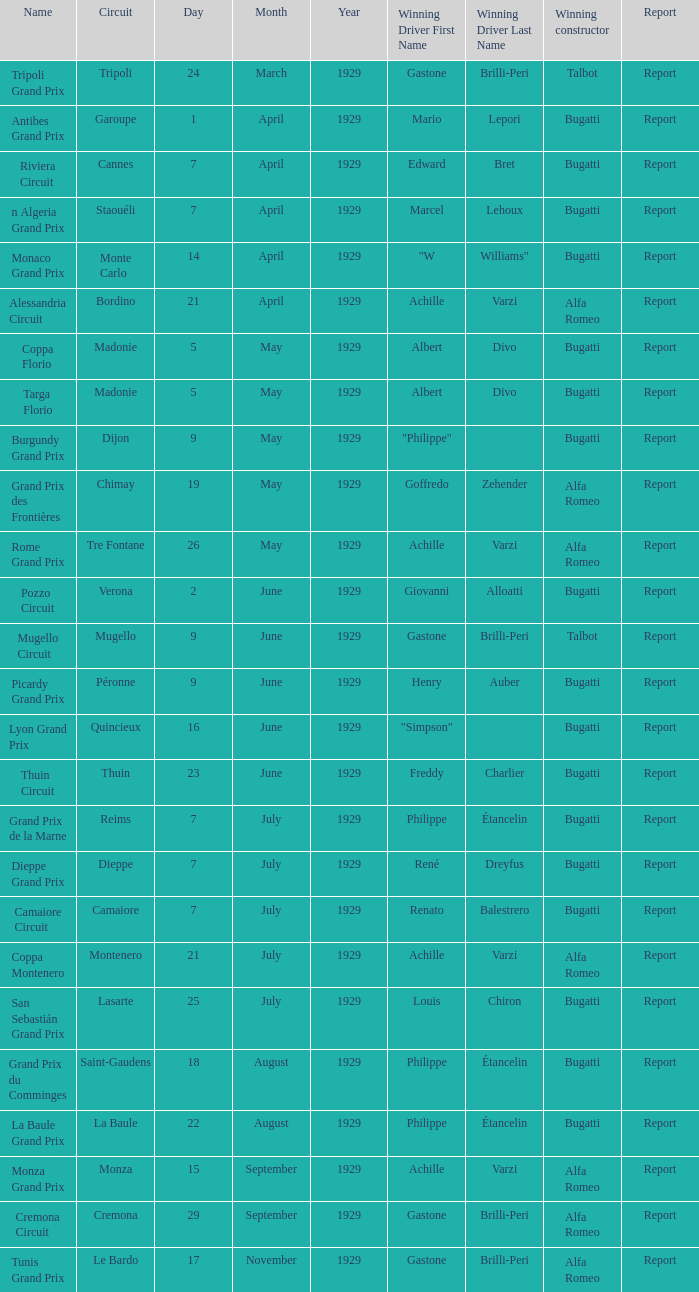What Name has a Winning constructor of bugatti, and a Winning driver of louis chiron? San Sebastián Grand Prix. 